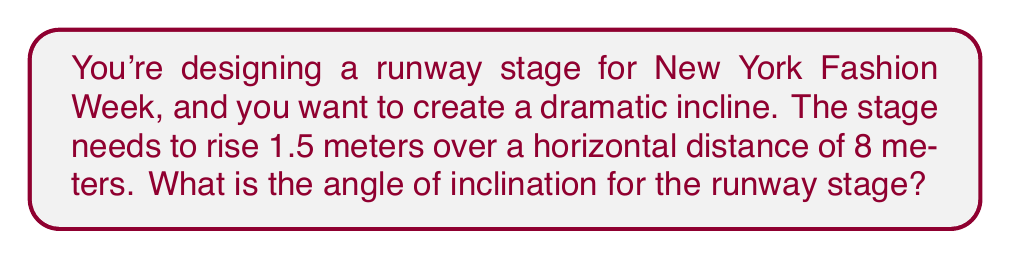Provide a solution to this math problem. To find the angle of inclination, we need to use trigonometry. Let's approach this step-by-step:

1. Visualize the runway as a right triangle:
   [asy]
   import geometry;
   size(200);
   pair A=(0,0), B=(8,0), C=(8,1.5);
   draw(A--B--C--A);
   label("8 m",B,(0,-1));
   label("1.5 m",C,(1,0));
   label("θ",A,(0.5,0.5));
   draw(A--A+(0.5,0), arrow=Arrow(TeXHead));
   draw(A--A+(0,0.5), arrow=Arrow(TeXHead));
   [/asy]

2. In this right triangle:
   - The opposite side is the vertical rise: 1.5 meters
   - The adjacent side is the horizontal distance: 8 meters
   - We need to find the angle θ

3. We can use the tangent function, which is defined as:
   $$ \tan(\theta) = \frac{\text{opposite}}{\text{adjacent}} $$

4. Plugging in our values:
   $$ \tan(\theta) = \frac{1.5}{8} $$

5. To find θ, we need to use the inverse tangent (arctan or tan⁻¹):
   $$ \theta = \tan^{-1}\left(\frac{1.5}{8}\right) $$

6. Using a calculator or computer:
   $$ \theta \approx 10.62° $$

7. Round to the nearest tenth of a degree:
   $$ \theta \approx 10.6° $$
Answer: $10.6°$ 